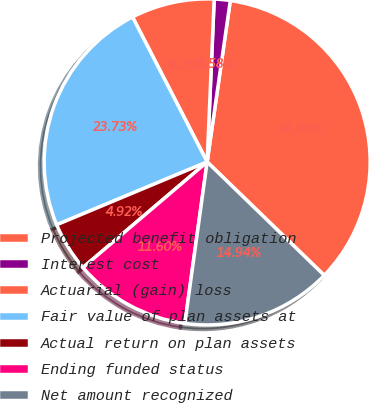Convert chart to OTSL. <chart><loc_0><loc_0><loc_500><loc_500><pie_chart><fcel>Projected benefit obligation<fcel>Interest cost<fcel>Actuarial (gain) loss<fcel>Fair value of plan assets at<fcel>Actual return on plan assets<fcel>Ending funded status<fcel>Net amount recognized<nl><fcel>34.98%<fcel>1.58%<fcel>8.26%<fcel>23.73%<fcel>4.92%<fcel>11.6%<fcel>14.94%<nl></chart> 